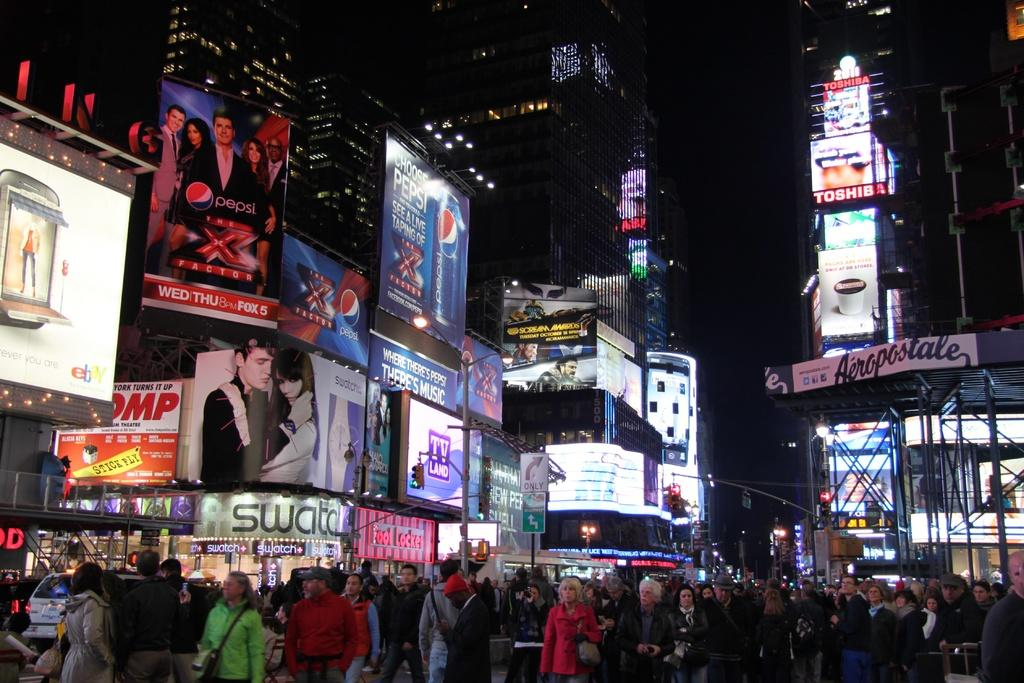<image>
Share a concise interpretation of the image provided. In Times Square there is an ad for The X Factor, sponsored by Pepsi, for WED and THU on FOX 5. 